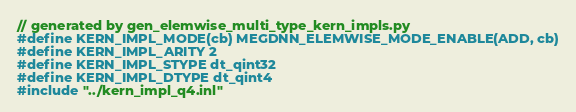<code> <loc_0><loc_0><loc_500><loc_500><_Cuda_>// generated by gen_elemwise_multi_type_kern_impls.py
#define KERN_IMPL_MODE(cb) MEGDNN_ELEMWISE_MODE_ENABLE(ADD, cb)
#define KERN_IMPL_ARITY 2
#define KERN_IMPL_STYPE dt_qint32
#define KERN_IMPL_DTYPE dt_qint4
#include "../kern_impl_q4.inl"
</code> 